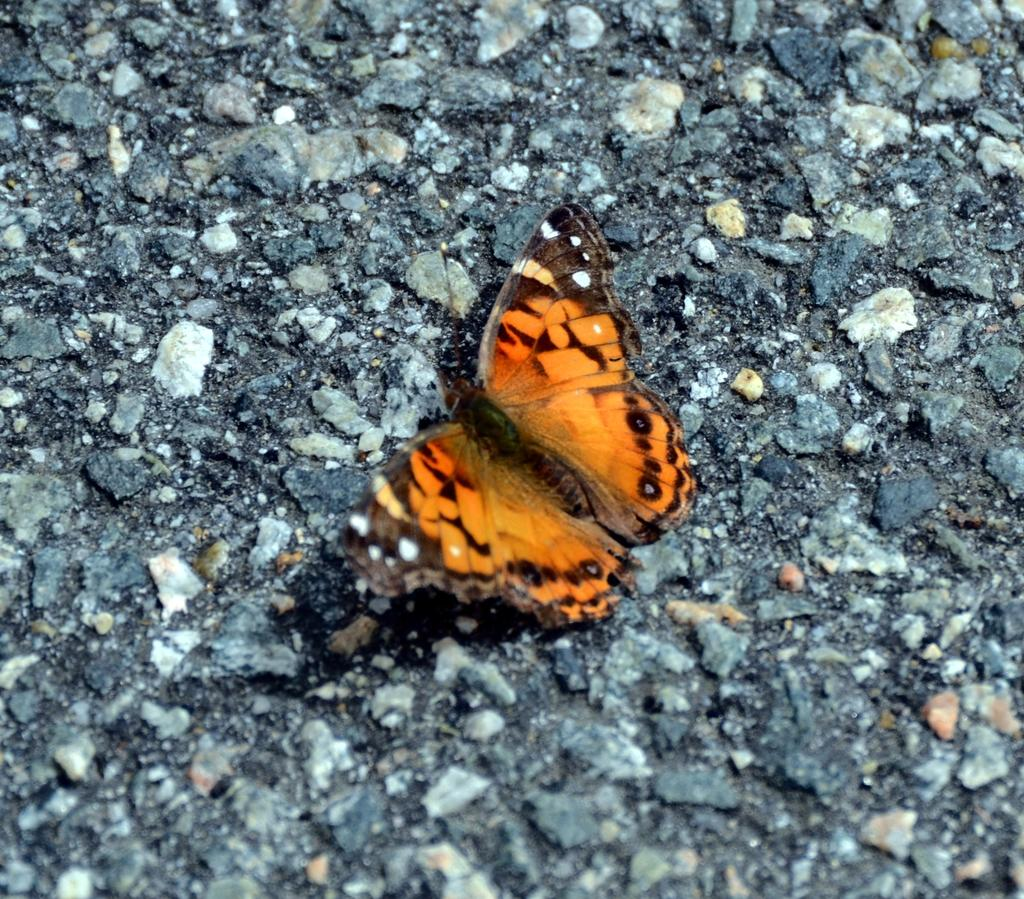What type of creature is present in the image? There is a butterfly in the image. Where is the butterfly located in the image? The butterfly is on the surface. What type of government is depicted in the image? There is no depiction of a government in the image; it features a butterfly on the surface. What type of brick is visible in the image? There is no brick present in the image. 